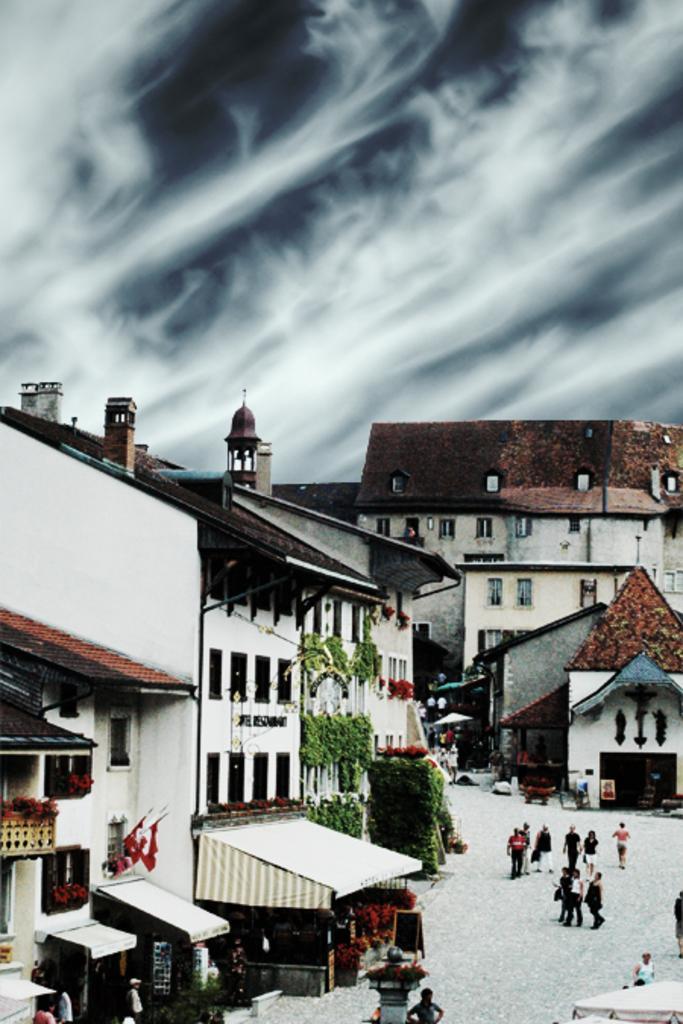Describe this image in one or two sentences. In the image there are few people walking on road on the right side and behind there are homes and above its sky with clouds. 